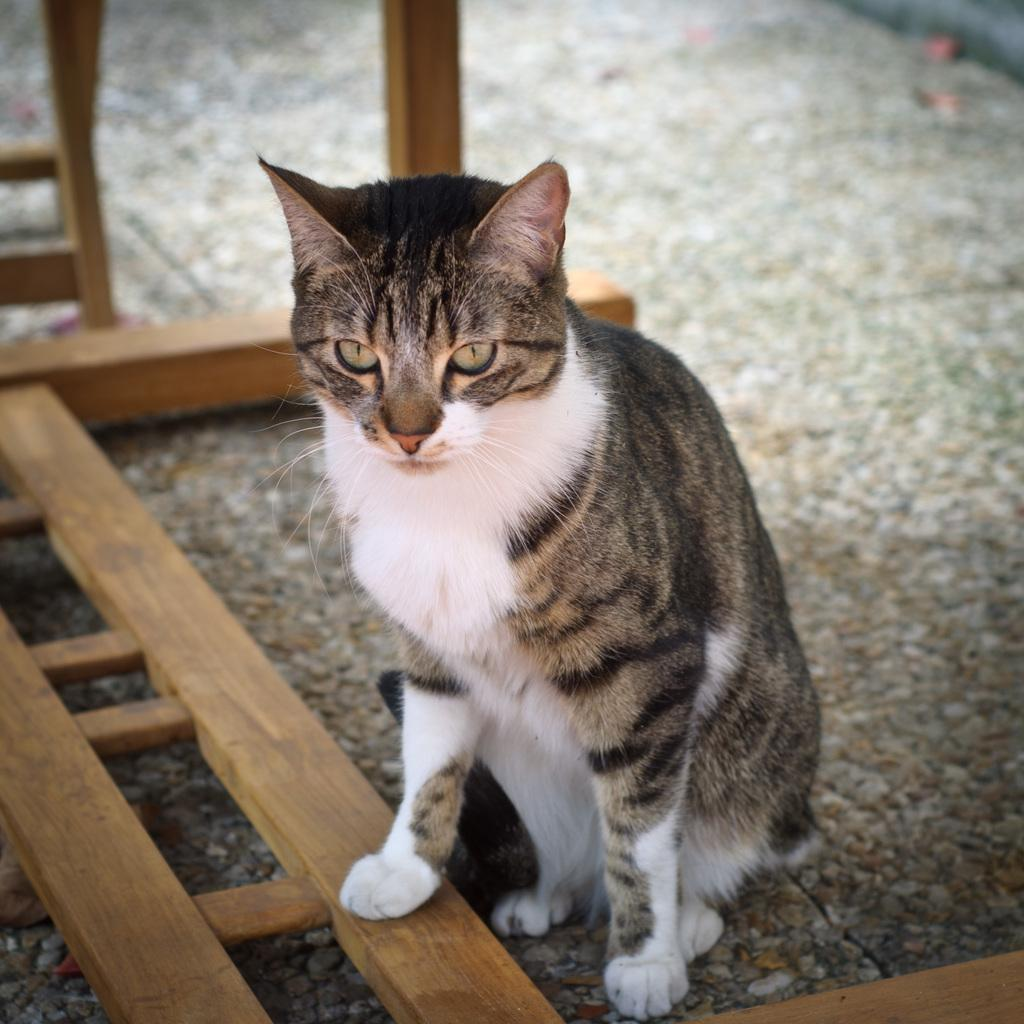What animal is sitting on the floor in the image? There is a cat sitting on the floor in the image. What type of objects are on the floor with the cat? There are wooden objects on the floor. What are the small pink objects on the floor? There are three small pink objects on the floor. Can you describe the background of the image? The background of the image is blurred. What type of glue is being used to hold the agreement in the image? There is no glue or agreement present in the image; it features a cat sitting on the floor with wooden and small pink objects. What type of cloud can be seen in the image? There is no cloud present in the image; the background is blurred. 